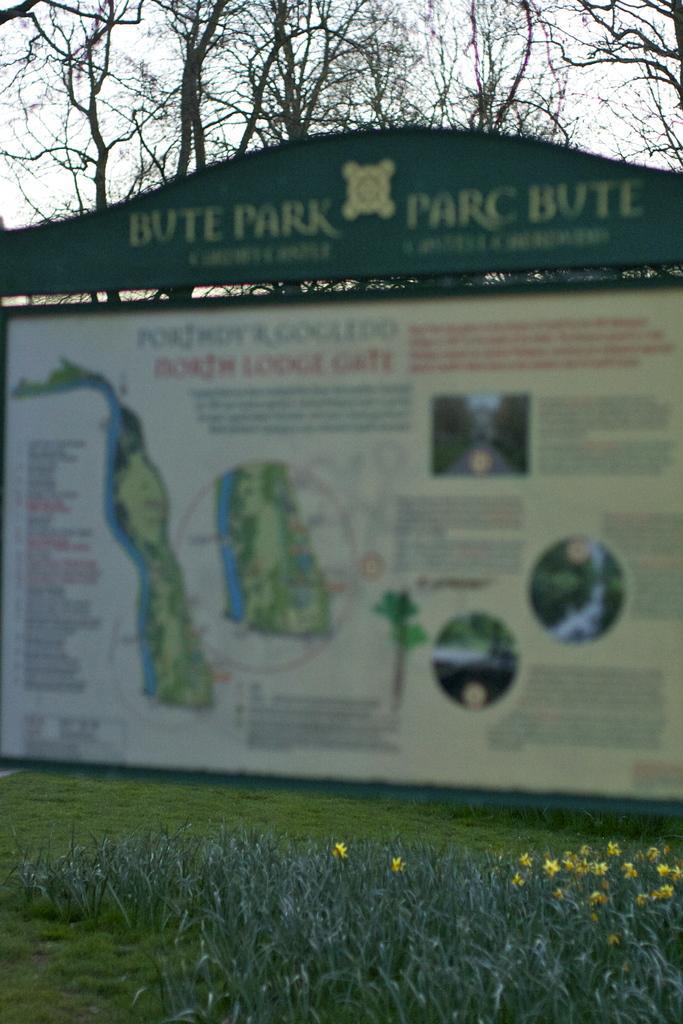In one or two sentences, can you explain what this image depicts? In this image I can see a board. There are few pictures and some text on it. I can see grass on the wall. I can see few trees. I can see the sky. 